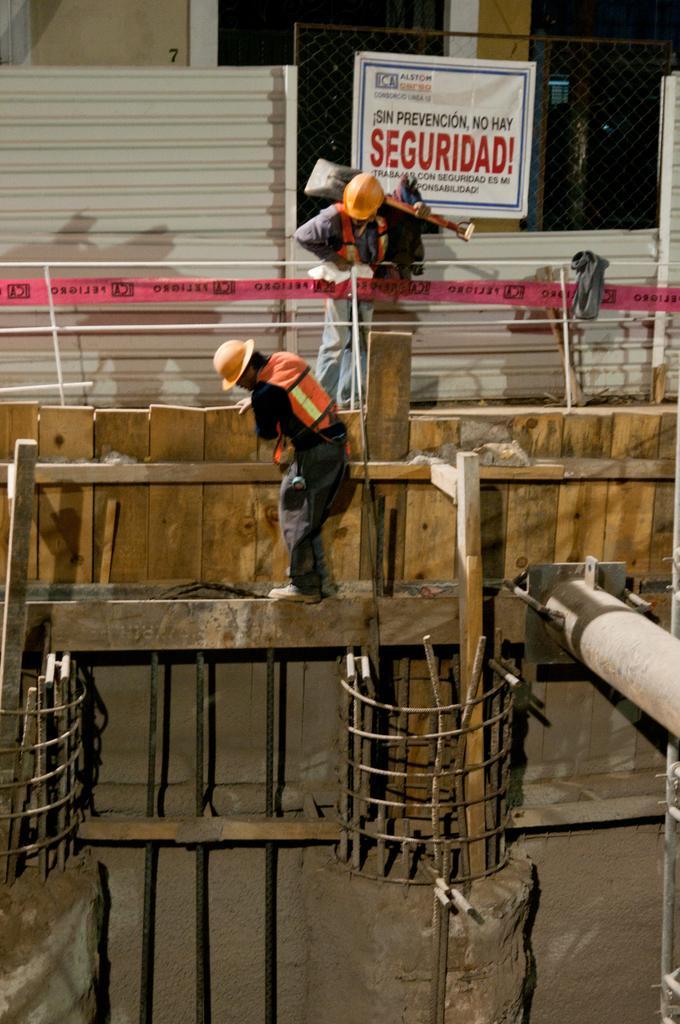How would you summarize this image in a sentence or two? The image is taken at the construction area. In the center we can see a man constructing a wall. In the background there is a man standing and holding an object in his hand. We can see a board, mesh and building. 